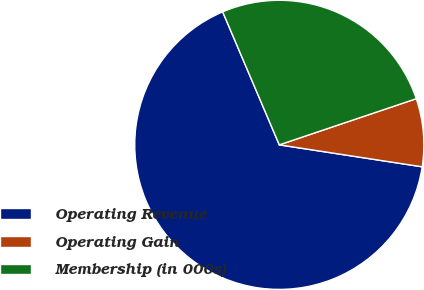<chart> <loc_0><loc_0><loc_500><loc_500><pie_chart><fcel>Operating Revenue<fcel>Operating Gain<fcel>Membership (in 000s)<nl><fcel>66.16%<fcel>7.6%<fcel>26.23%<nl></chart> 